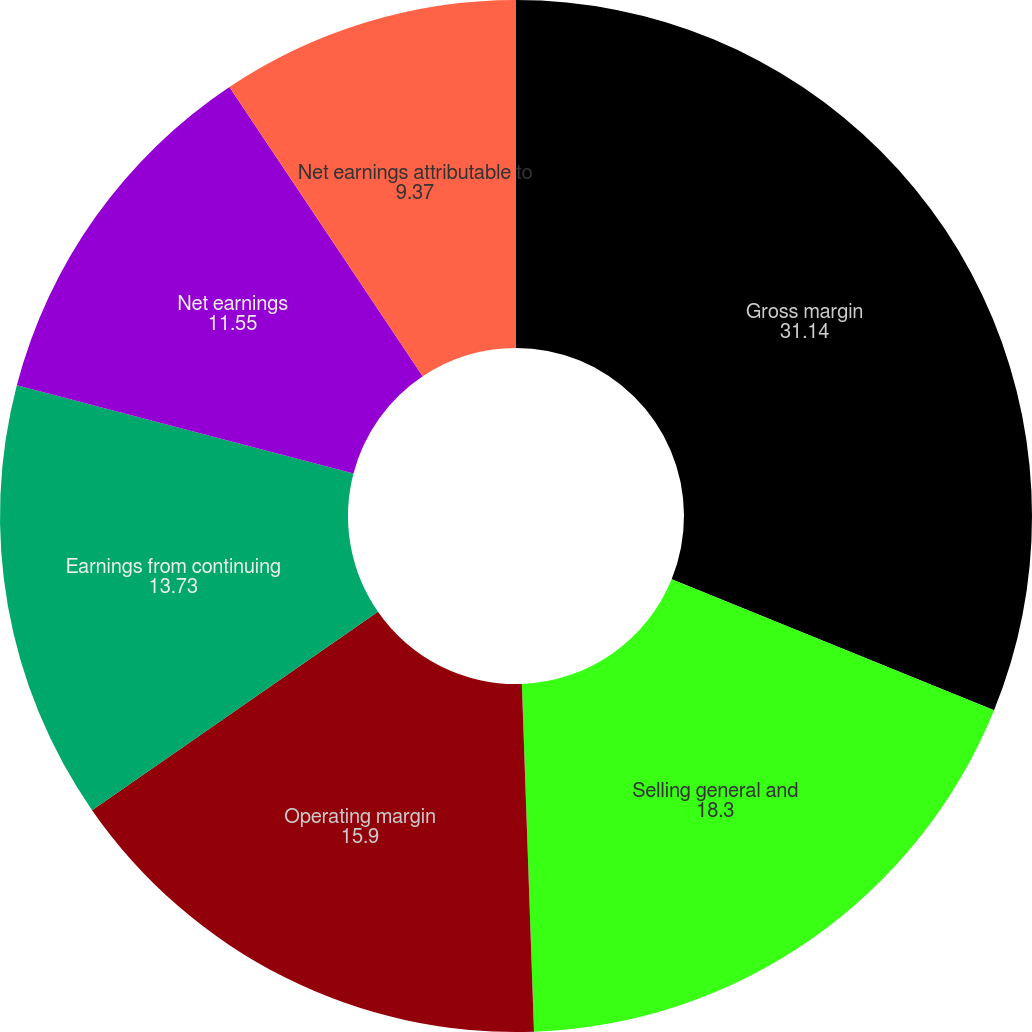Convert chart. <chart><loc_0><loc_0><loc_500><loc_500><pie_chart><fcel>Gross margin<fcel>Selling general and<fcel>Operating margin<fcel>Earnings from continuing<fcel>Net earnings<fcel>Net earnings attributable to<nl><fcel>31.14%<fcel>18.3%<fcel>15.9%<fcel>13.73%<fcel>11.55%<fcel>9.37%<nl></chart> 